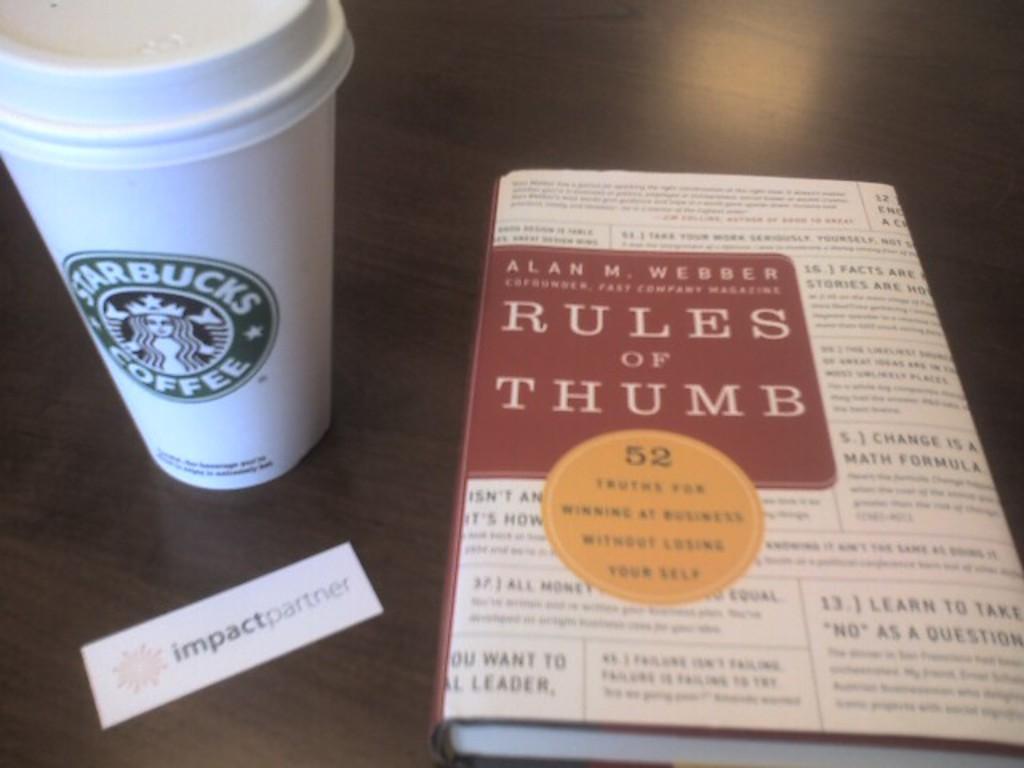Describe this image in one or two sentences. In the image there is a coffee mug along with a book on a table. 